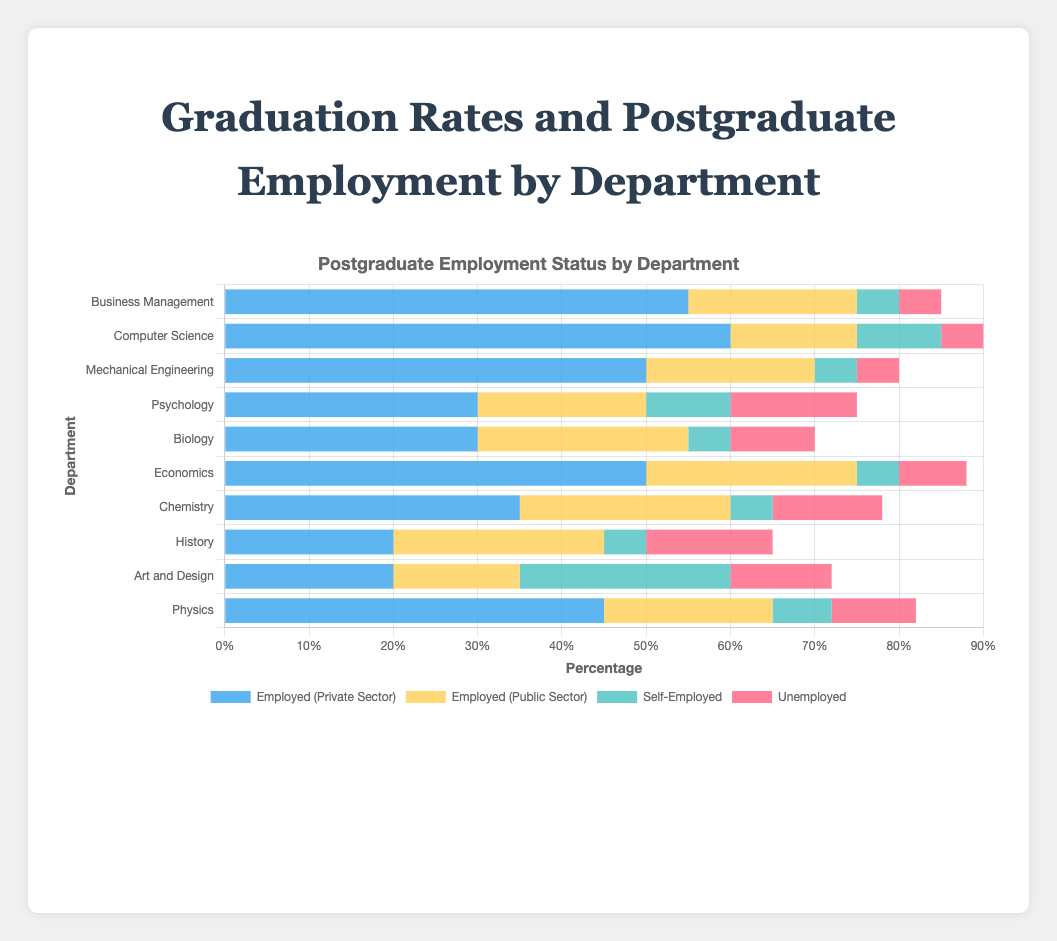Which department has the highest graduation rate? The Department of Computer Science has a graduation rate of 90%, which is the highest among all the departments listed in the figure.
Answer: Computer Science Which department has the lowest percentage of postgraduate unemployed individuals? The Department of Business Management, Computer Science, and Mechanical Engineering all have the lowest percentage of unemployed graduates, at 5%.
Answer: Business Management, Computer Science, and Mechanical Engineering Which two departments have the same percentage of graduates working in the public sector? The departments of Biology, Chemistry, and History each have 25% of their graduates employed in the public sector.
Answer: Biology, Chemistry, and History What is the total percentage of graduates in the Art and Design department who are either self-employed or unemployed? Combine the percentages from the Art and Design department for self-employed (25%) and unemployed (12%) to get a total of 25% + 12% = 37%.
Answer: 37% Which department has the largest proportion of self-employed graduates? The Department of Art and Design has the highest proportion of self-employed graduates at 25%.
Answer: Art and Design Compare the private sector employment between Computer Science and Psychology departments. The Computer Science department has 60% of its graduates employed in the private sector, while the Psychology department has 30%, indicating Computer Science has a higher private sector employment rate.
Answer: Computer Science has a higher rate How many departments have a graduation rate of 82% or higher? The departments with graduation rates of 82% or higher are Business Management (85%), Computer Science (90%), Economics (88%), and Physics (82%). This totals 4 departments.
Answer: 4 Which department has the highest combined percentage of graduates working in either the private or public sector? For each department, sum the percentages of graduates working in the private and public sectors:
- Business Management: 55% + 20% = 75%
- Computer Science: 60% + 15% = 75%
- Mechanical Engineering: 50% + 20% = 70%
- Psychology: 30% + 20% = 50%
- Biology: 30% + 25% = 55%
- Economics: 50% + 25% = 75%
- Chemistry: 35% + 25% = 60%
- History: 20% + 25% = 45%
- Art and Design: 20% + 15% = 35%
- Physics: 45% + 20% = 65%
Departments with the highest combined percentage are Business Management, Computer Science, and Economics, all at 75%.
Answer: Business Management, Computer Science, and Economics 